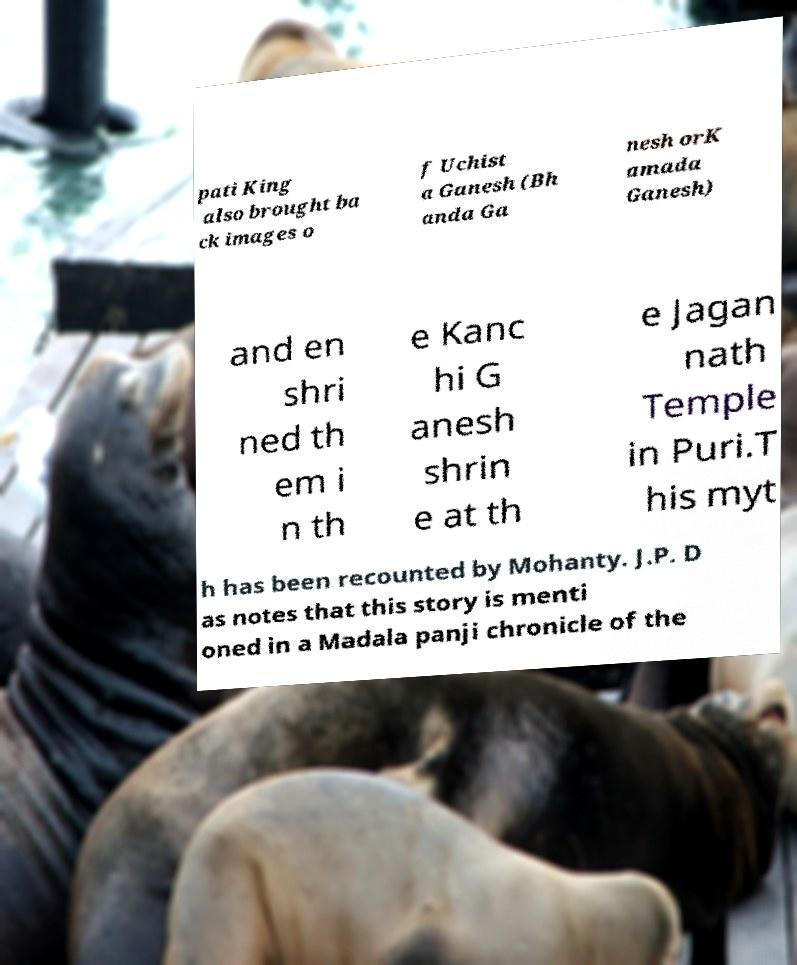Can you accurately transcribe the text from the provided image for me? pati King also brought ba ck images o f Uchist a Ganesh (Bh anda Ga nesh orK amada Ganesh) and en shri ned th em i n th e Kanc hi G anesh shrin e at th e Jagan nath Temple in Puri.T his myt h has been recounted by Mohanty. J.P. D as notes that this story is menti oned in a Madala panji chronicle of the 